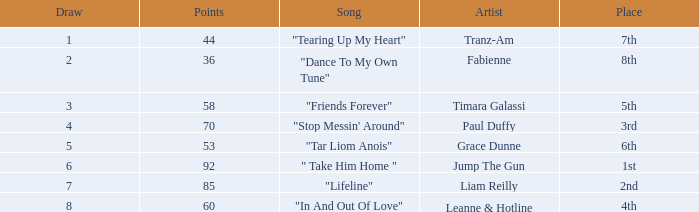What's the total number of points for grace dunne with a draw over 5? 0.0. 